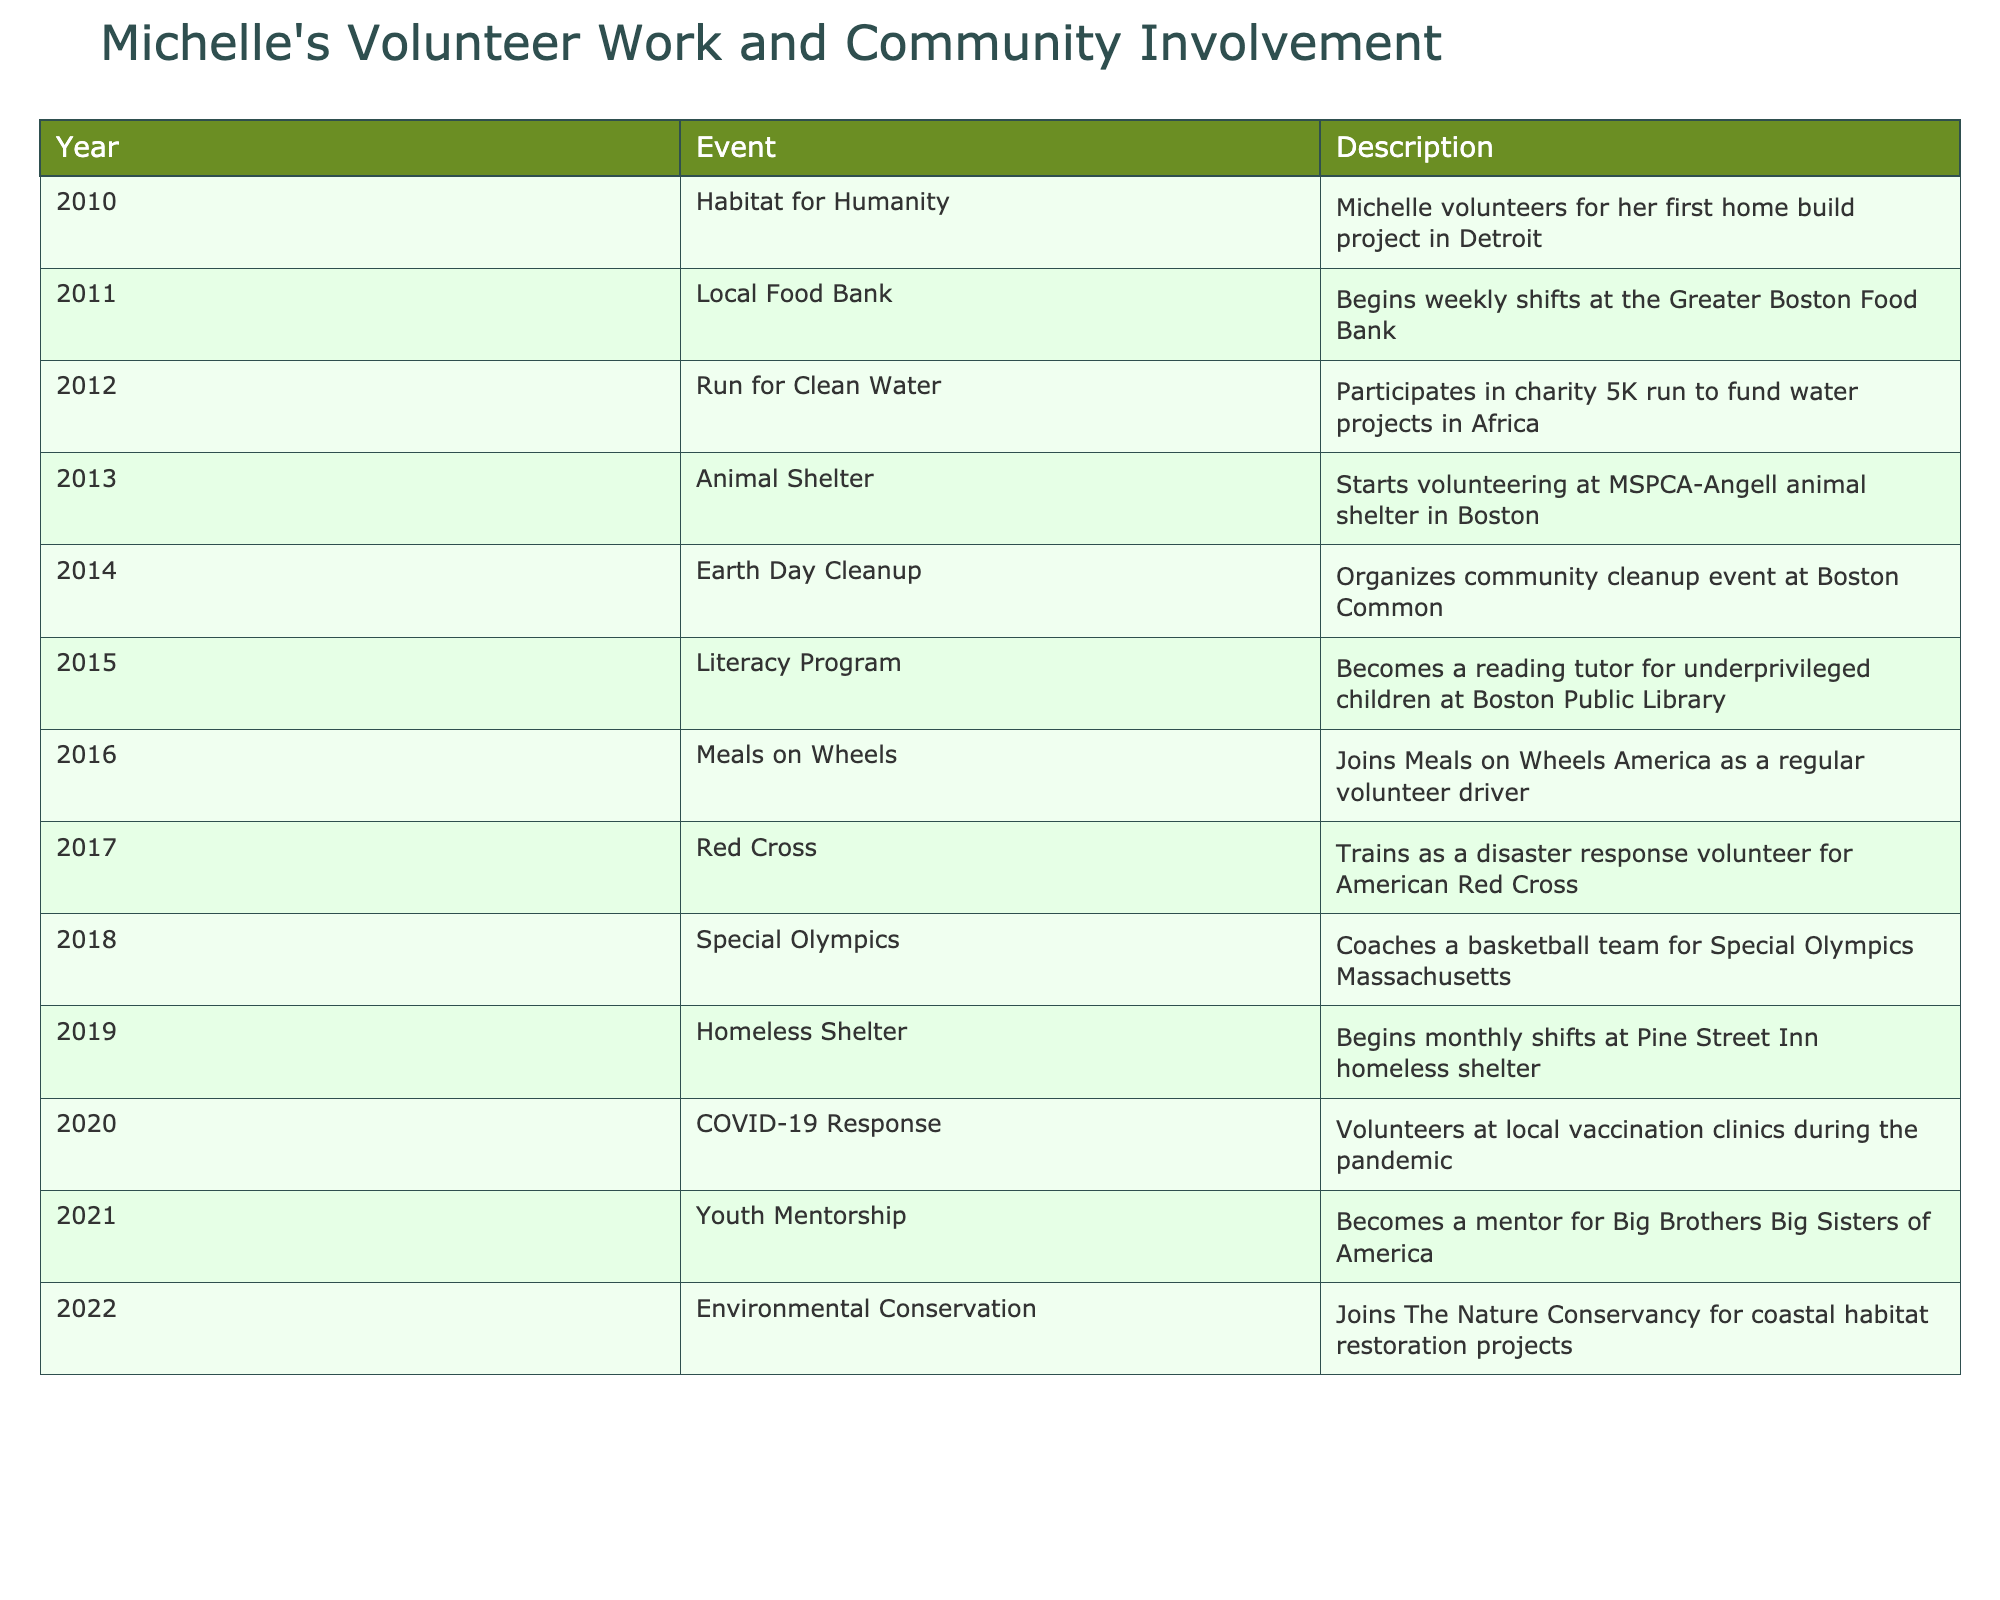What year did Michelle start volunteering with Habitat for Humanity? The table shows that Michelle volunteered for her first home build project with Habitat for Humanity in 2010.
Answer: 2010 How many years did Michelle volunteer at the Greater Boston Food Bank? According to the table, Michelle began volunteering at the Greater Boston Food Bank in 2011 and there is no end date mentioned, thus she volunteered until at least 2012. Therefore, it can be inferred she volunteered there for at least 1 year.
Answer: At least 1 year Did Michelle volunteer for the Special Olympics? The table indicates that Michelle coached a basketball team for the Special Olympics Massachusetts in 2018, confirming that she did volunteer for this organization.
Answer: Yes How many volunteer activities did Michelle participate in from 2010 to 2015? The table lists volunteer activities from 2010 to 2015, specifically naming 6 activities: Habitat for Humanity (2010), Local Food Bank (2011), Run for Clean Water (2012), Animal Shelter (2013), Earth Day Cleanup (2014), and Literacy Program (2015). Counting these gives us a total of 6 activities.
Answer: 6 Which volunteer activity did Michelle participate in during 2016? The table states that in 2016, Michelle joined Meals on Wheels America as a regular volunteer driver. This information confirms her specific activity in that year.
Answer: Meals on Wheels What is the total number of unique organizations Michelle has been involved with from 2010 to 2022? Upon review of the table, the unique organizations are: Habitat for Humanity, Greater Boston Food Bank, Run for Clean Water, MSPCA-Angell, Earth Day Cleanup, Boston Public Library, Meals on Wheels America, American Red Cross, Special Olympics Massachusetts, Pine Street Inn, local vaccination clinics, Big Brothers Big Sisters of America, and The Nature Conservancy. Counting these results in a total of 13 unique organizations.
Answer: 13 In which year did Michelle start volunteering as a reading tutor? The table indicates that Michelle became a reading tutor for underprivileged children at the Boston Public Library in 2015. This gives the exact year she started this activity.
Answer: 2015 How many years did Michelle contribute to community initiatives without a break from 2010 to 2022? Reviewing the table, each year from 2010 to 2022 shows a different activity, indicating ongoing volunteer work every year. Therefore, the answer is 13 years (from 2010 to 2022).
Answer: 13 years 